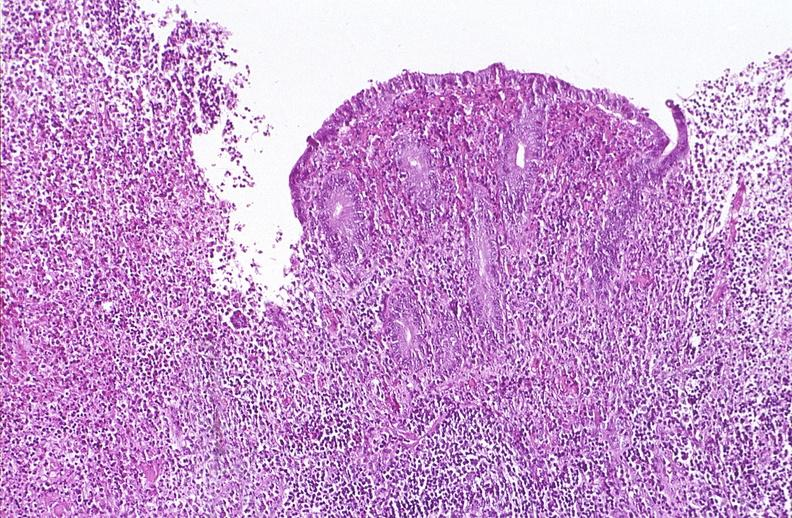what is present?
Answer the question using a single word or phrase. Gastrointestinal 